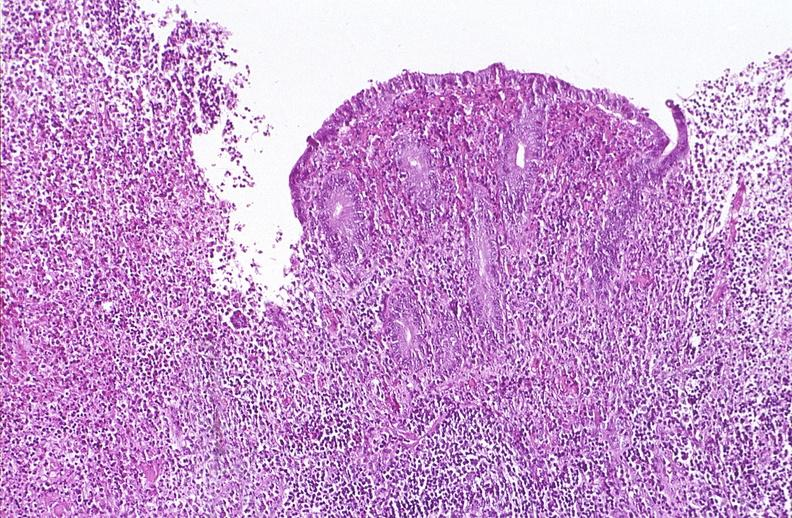what is present?
Answer the question using a single word or phrase. Gastrointestinal 